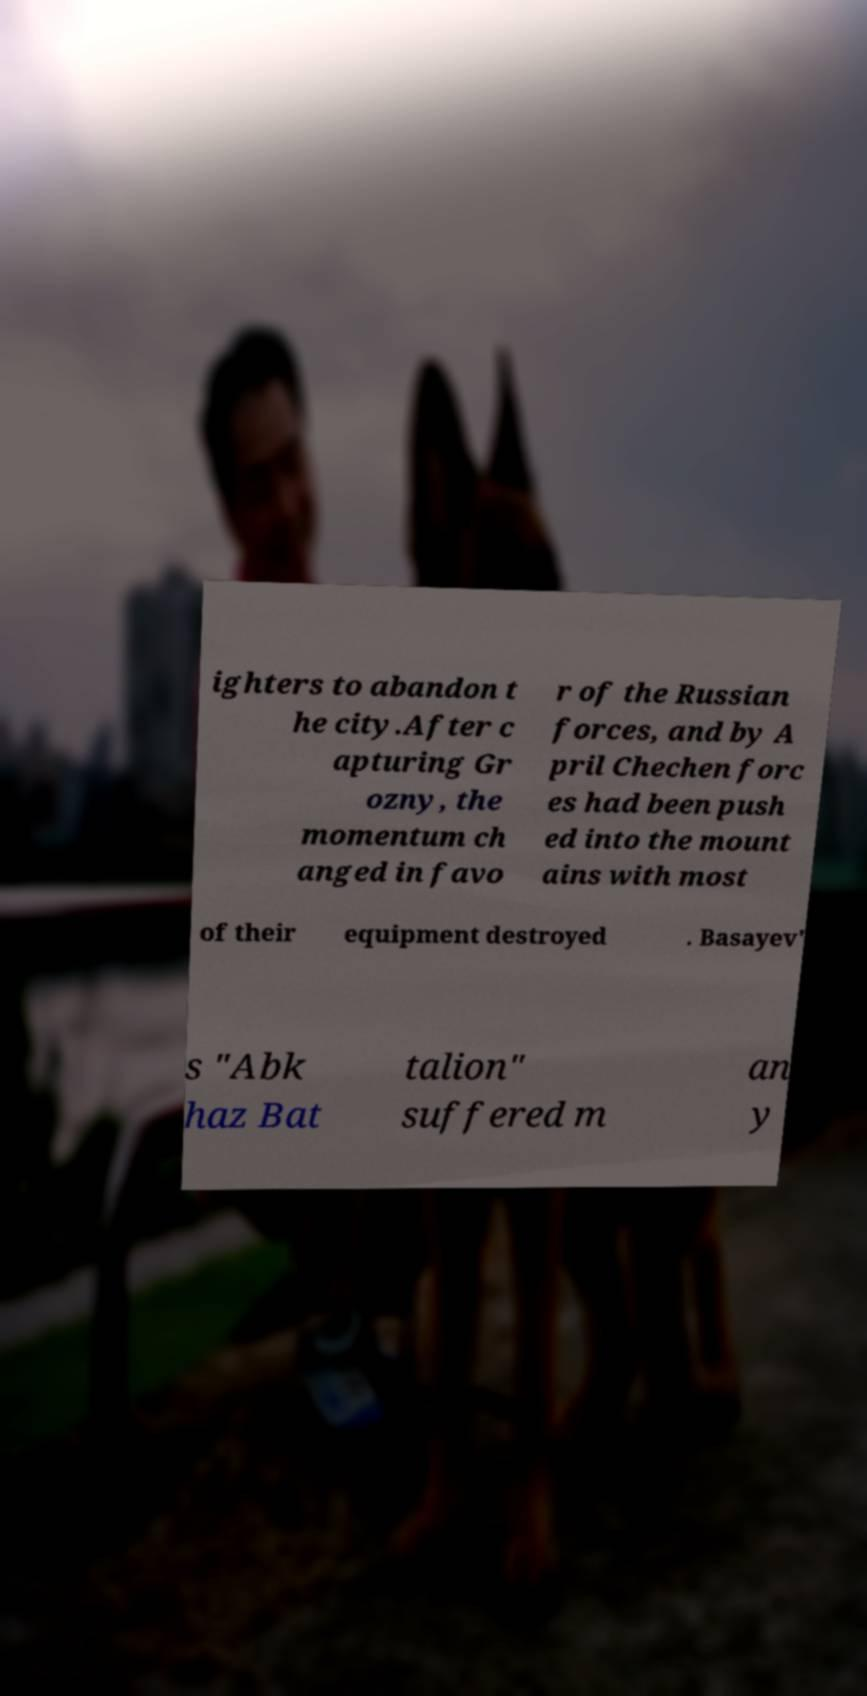Could you extract and type out the text from this image? ighters to abandon t he city.After c apturing Gr ozny, the momentum ch anged in favo r of the Russian forces, and by A pril Chechen forc es had been push ed into the mount ains with most of their equipment destroyed . Basayev' s "Abk haz Bat talion" suffered m an y 